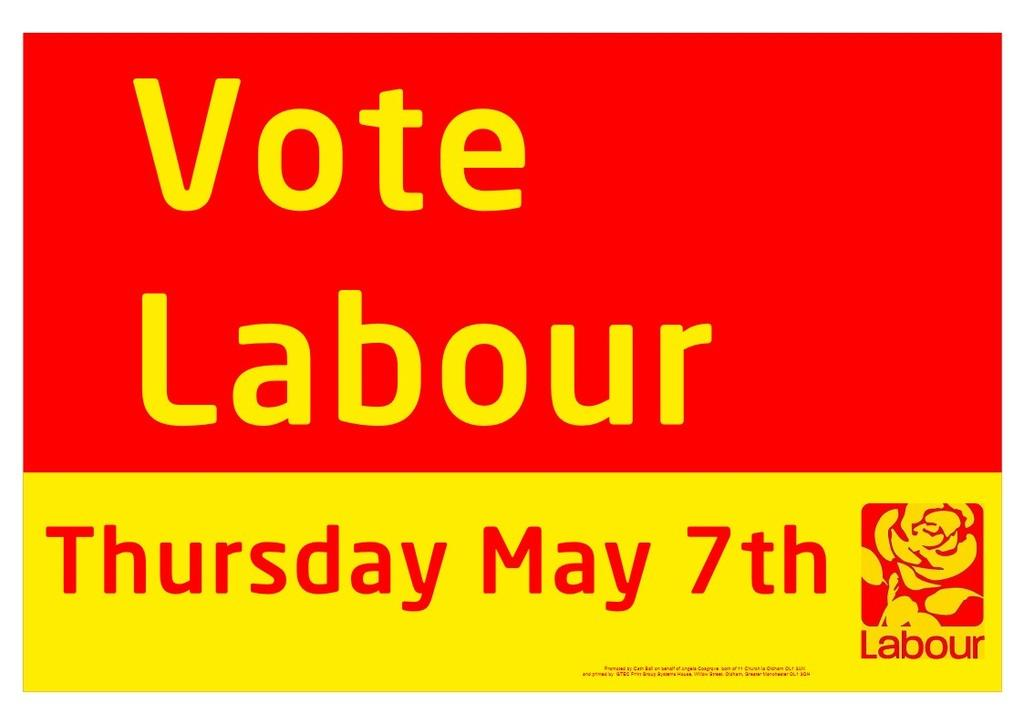<image>
Share a concise interpretation of the image provided. A red and yellow sign advertises that voting day is May 7th. 